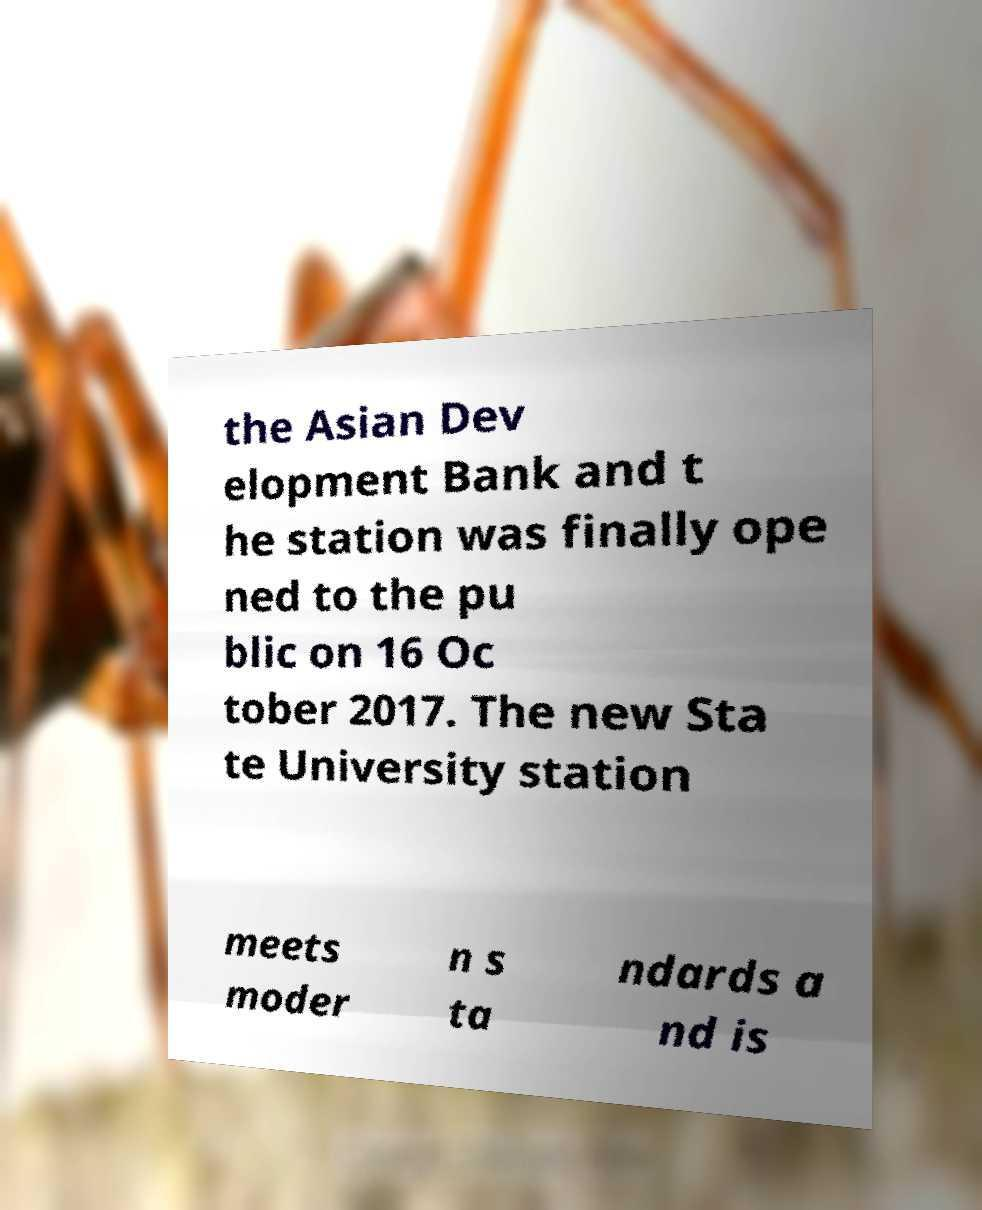Could you assist in decoding the text presented in this image and type it out clearly? the Asian Dev elopment Bank and t he station was finally ope ned to the pu blic on 16 Oc tober 2017. The new Sta te University station meets moder n s ta ndards a nd is 